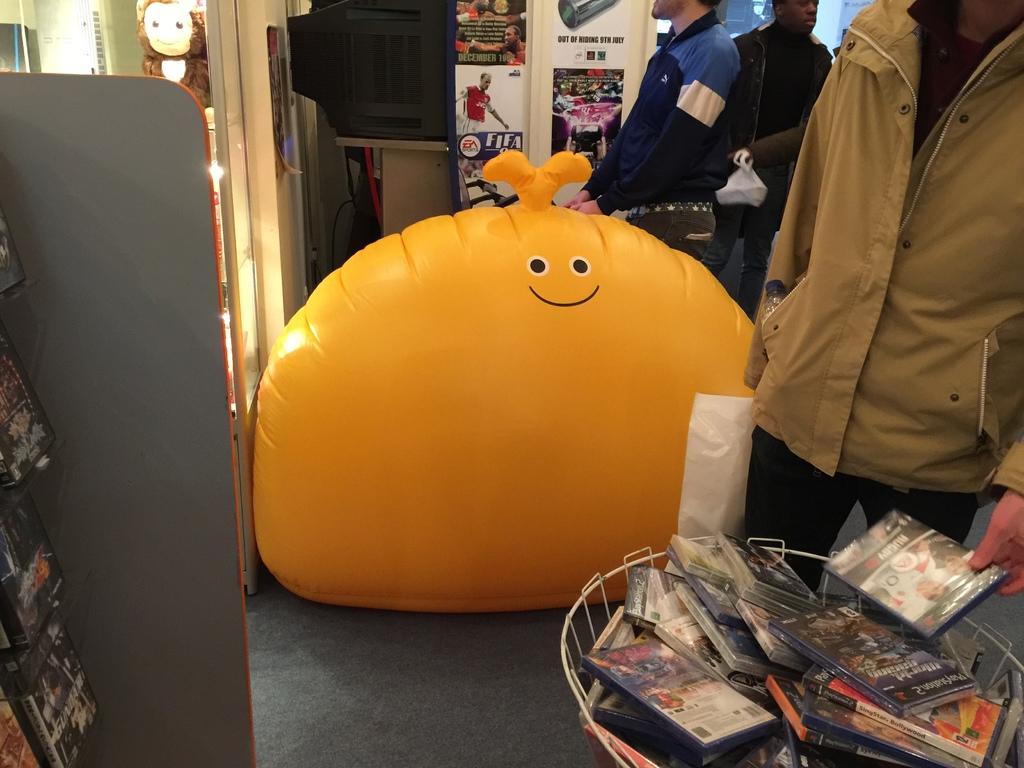What gaming console would be used to play the games in the basket in the front right?
Make the answer very short. Playstation 2. What is one game being advertised on the wall way in the back?
Keep it short and to the point. Fifa. 